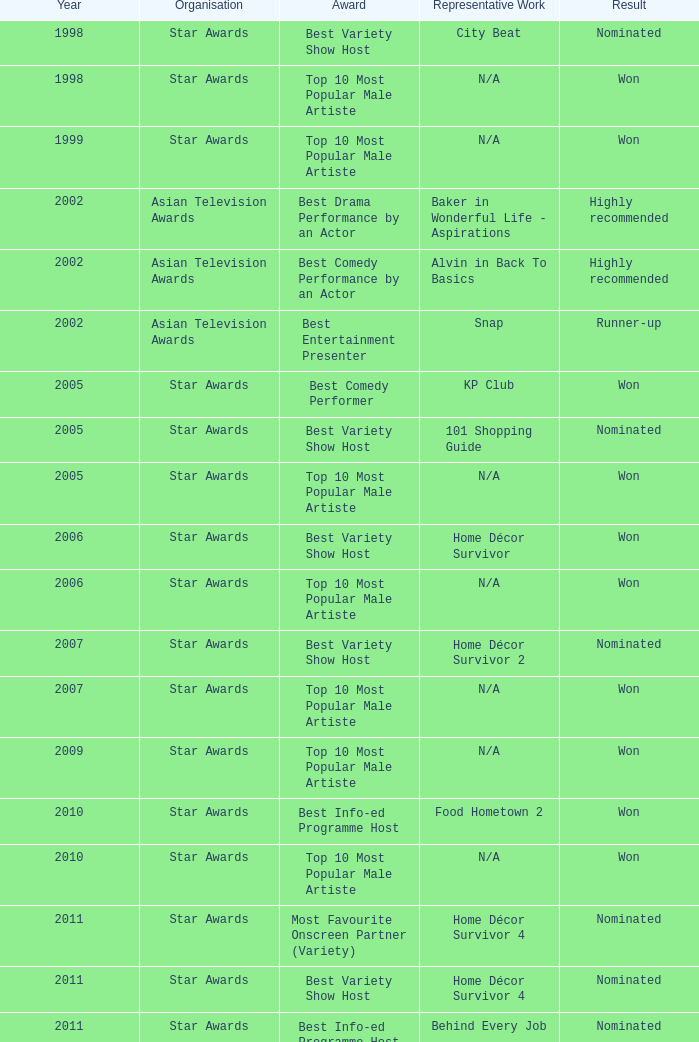What is the name of the nominated representative work, with a best variety show host award, in a year post-2005? Home Décor Survivor 2, Home Décor Survivor 4, Rénaissance, Jobs Around The World. Write the full table. {'header': ['Year', 'Organisation', 'Award', 'Representative Work', 'Result'], 'rows': [['1998', 'Star Awards', 'Best Variety Show Host', 'City Beat', 'Nominated'], ['1998', 'Star Awards', 'Top 10 Most Popular Male Artiste', 'N/A', 'Won'], ['1999', 'Star Awards', 'Top 10 Most Popular Male Artiste', 'N/A', 'Won'], ['2002', 'Asian Television Awards', 'Best Drama Performance by an Actor', 'Baker in Wonderful Life - Aspirations', 'Highly recommended'], ['2002', 'Asian Television Awards', 'Best Comedy Performance by an Actor', 'Alvin in Back To Basics', 'Highly recommended'], ['2002', 'Asian Television Awards', 'Best Entertainment Presenter', 'Snap', 'Runner-up'], ['2005', 'Star Awards', 'Best Comedy Performer', 'KP Club', 'Won'], ['2005', 'Star Awards', 'Best Variety Show Host', '101 Shopping Guide', 'Nominated'], ['2005', 'Star Awards', 'Top 10 Most Popular Male Artiste', 'N/A', 'Won'], ['2006', 'Star Awards', 'Best Variety Show Host', 'Home Décor Survivor', 'Won'], ['2006', 'Star Awards', 'Top 10 Most Popular Male Artiste', 'N/A', 'Won'], ['2007', 'Star Awards', 'Best Variety Show Host', 'Home Décor Survivor 2', 'Nominated'], ['2007', 'Star Awards', 'Top 10 Most Popular Male Artiste', 'N/A', 'Won'], ['2009', 'Star Awards', 'Top 10 Most Popular Male Artiste', 'N/A', 'Won'], ['2010', 'Star Awards', 'Best Info-ed Programme Host', 'Food Hometown 2', 'Won'], ['2010', 'Star Awards', 'Top 10 Most Popular Male Artiste', 'N/A', 'Won'], ['2011', 'Star Awards', 'Most Favourite Onscreen Partner (Variety)', 'Home Décor Survivor 4', 'Nominated'], ['2011', 'Star Awards', 'Best Variety Show Host', 'Home Décor Survivor 4', 'Nominated'], ['2011', 'Star Awards', 'Best Info-ed Programme Host', 'Behind Every Job', 'Nominated'], ['2011', 'Star Awards', 'Top 10 Most Popular Male Artiste', 'N/A', 'Won'], ['2012', 'Star Awards', 'Favourite Variety Show Host', 'N/A', 'Won'], ['2012', 'Star Awards', 'Best Variety Show Host', 'Rénaissance', 'Nominated'], ['2012', 'Star Awards', 'Best Info-ed Programme Host', 'Behind Every Job 2', 'Nominated'], ['2012', 'Star Awards', 'Top 10 Most Popular Male Artiste', 'N/A', 'Won'], ['2013', 'Star Awards', 'Favourite Variety Show Host', 'S.N.A.P. 熠熠星光总动员', 'Won'], ['2013', 'Star Awards', 'Top 10 Most Popular Male Artiste', 'N/A', 'Won'], ['2013', 'Star Awards', 'Best Info-Ed Programme Host', 'Makan Unlimited', 'Nominated'], ['2013', 'Star Awards', 'Best Variety Show Host', 'Jobs Around The World', 'Nominated']]} 